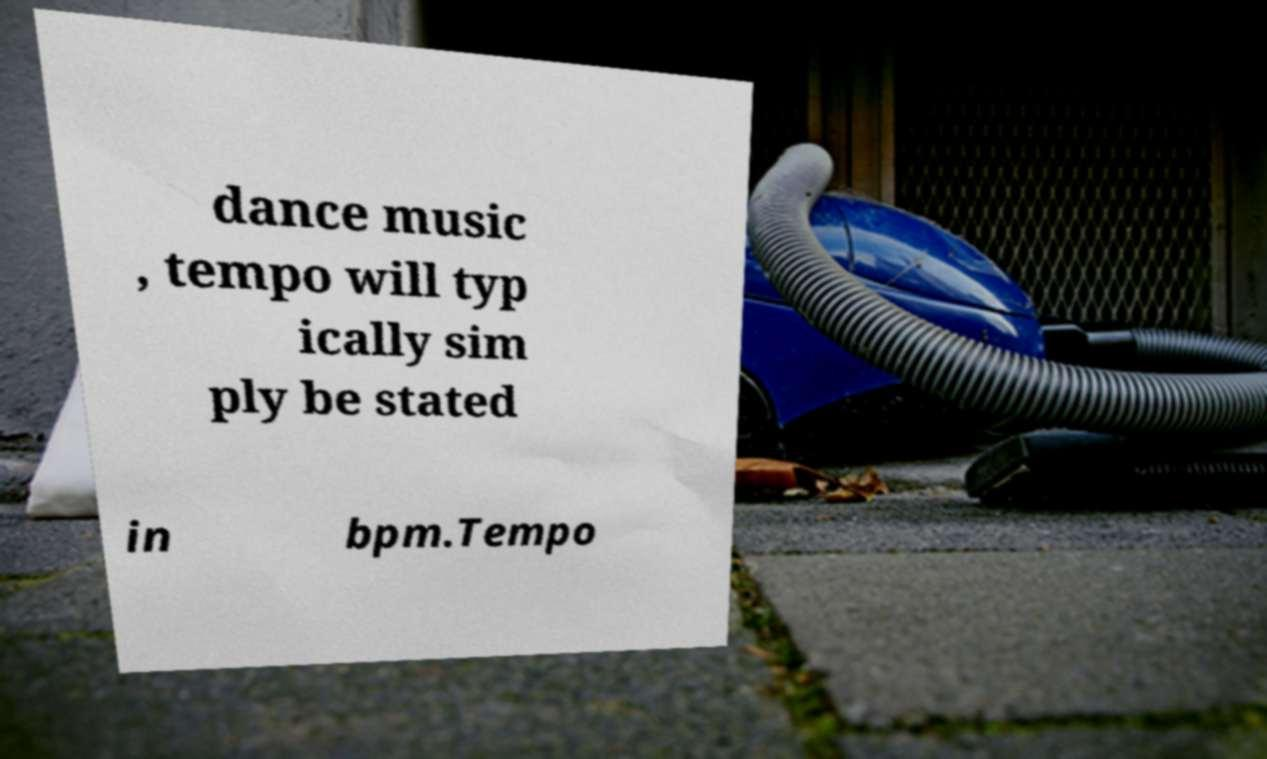For documentation purposes, I need the text within this image transcribed. Could you provide that? dance music , tempo will typ ically sim ply be stated in bpm.Tempo 